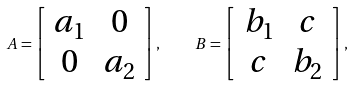<formula> <loc_0><loc_0><loc_500><loc_500>A = \left [ \begin{array} { c c } a _ { 1 } & 0 \\ 0 & a _ { 2 } \\ \end{array} \right ] , \quad B = \left [ \begin{array} { c c } b _ { 1 } & c \\ c & b _ { 2 } \\ \end{array} \right ] ,</formula> 